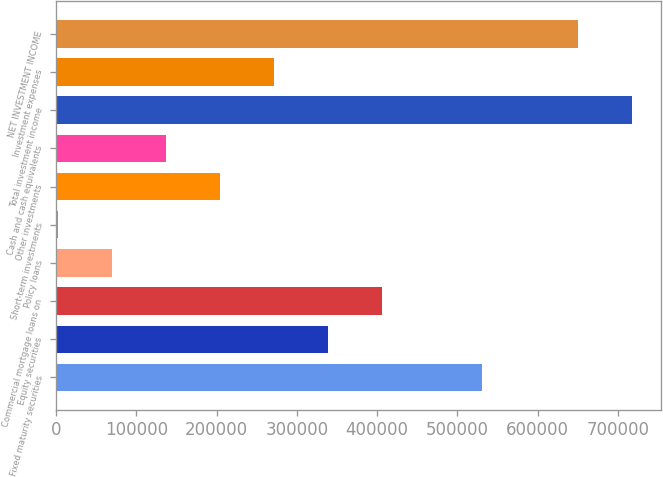Convert chart to OTSL. <chart><loc_0><loc_0><loc_500><loc_500><bar_chart><fcel>Fixed maturity securities<fcel>Equity securities<fcel>Commercial mortgage loans on<fcel>Policy loans<fcel>Short-term investments<fcel>Other investments<fcel>Cash and cash equivalents<fcel>Total investment income<fcel>Investment expenses<fcel>NET INVESTMENT INCOME<nl><fcel>530144<fcel>338406<fcel>405656<fcel>69406<fcel>2156<fcel>203906<fcel>136656<fcel>717546<fcel>271156<fcel>650296<nl></chart> 